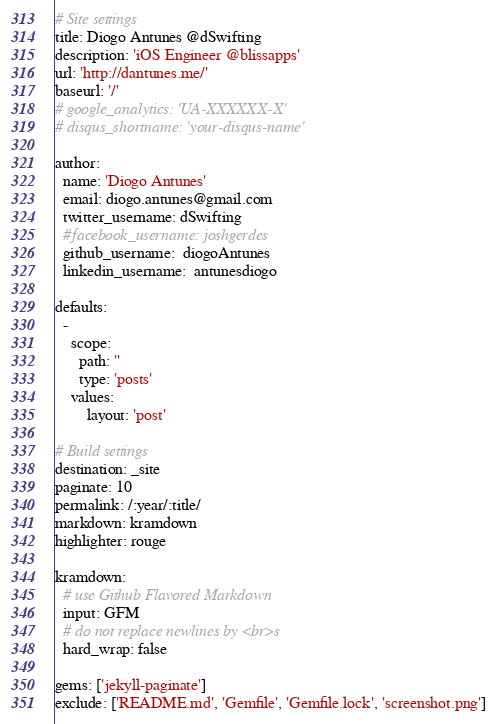<code> <loc_0><loc_0><loc_500><loc_500><_YAML_># Site settings
title: Diogo Antunes @dSwifting
description: 'iOS Engineer @blissapps'
url: 'http://dantunes.me/'
baseurl: '/'
# google_analytics: 'UA-XXXXXX-X'
# disqus_shortname: 'your-disqus-name'

author:
  name: 'Diogo Antunes'
  email: diogo.antunes@gmail.com
  twitter_username: dSwifting
  #facebook_username: joshgerdes
  github_username:  diogoAntunes
  linkedin_username:  antunesdiogo

defaults:
  -
    scope:
      path: ''
      type: 'posts'
    values:
        layout: 'post'

# Build settings
destination: _site
paginate: 10
permalink: /:year/:title/
markdown: kramdown
highlighter: rouge

kramdown:
  # use Github Flavored Markdown
  input: GFM
  # do not replace newlines by <br>s
  hard_wrap: false

gems: ['jekyll-paginate']
exclude: ['README.md', 'Gemfile', 'Gemfile.lock', 'screenshot.png']
</code> 